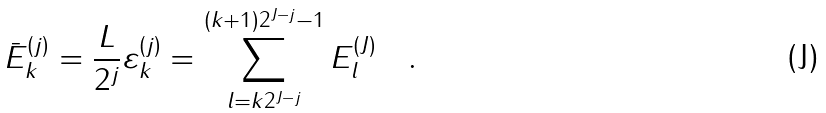<formula> <loc_0><loc_0><loc_500><loc_500>\bar { E } _ { k } ^ { ( j ) } = \frac { L } { 2 ^ { j } } \varepsilon _ { k } ^ { ( j ) } = \sum _ { l = k 2 ^ { J { - } j } } ^ { ( k + 1 ) 2 ^ { J - j } - 1 } E _ { l } ^ { ( J ) } \quad .</formula> 